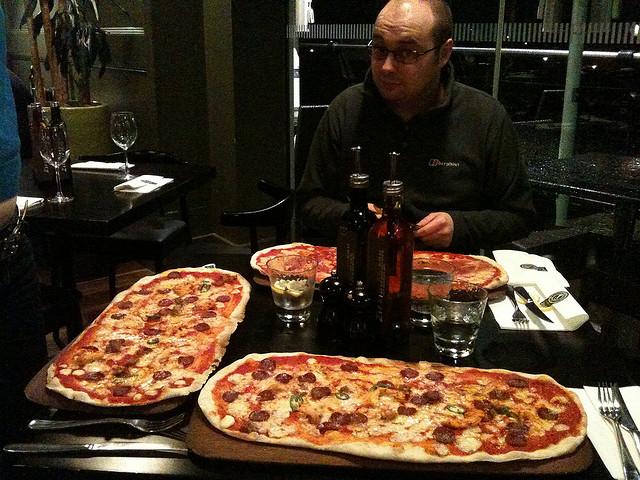Is the man by himself?
Answer briefly. Yes. What kind of food is on the table?
Answer briefly. Pizza. How many pizzas are there?
Short answer required. 3. 